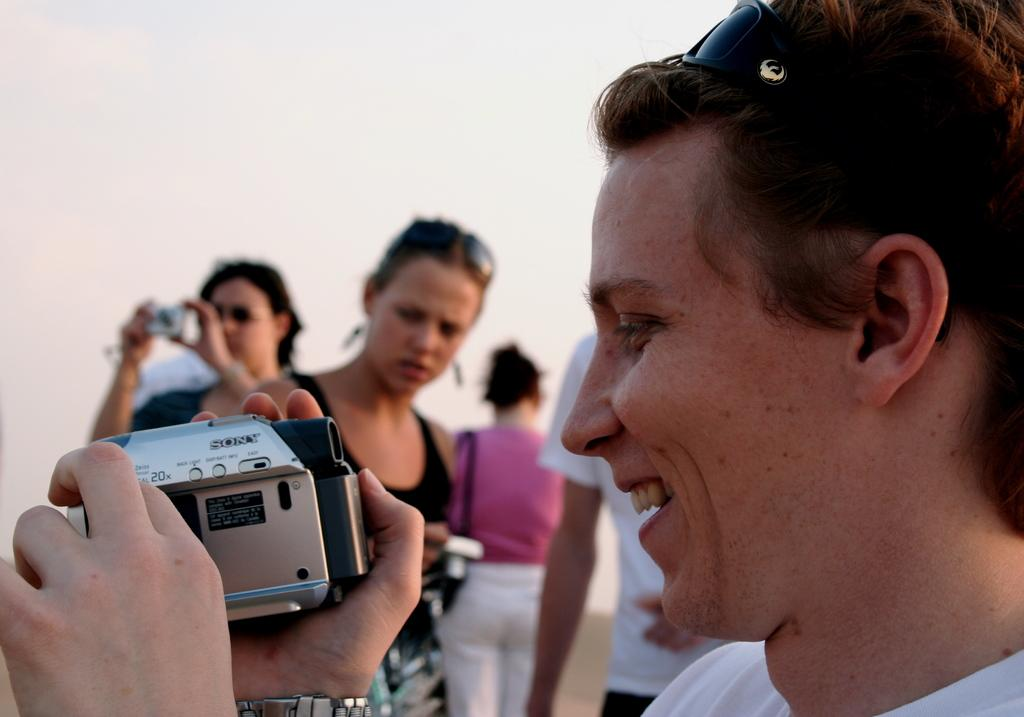Who is the main subject in the image? There is a woman in the image. What is the woman holding in her hand? The woman is holding a camera in her hand. What is the woman's facial expression in the image? The woman is smiling. Can you describe the actions of the other persons in the background of the image? There are other persons holding cameras in the background of the image. What type of brass instrument is the woman playing in the image? There is no brass instrument present in the image; the woman is holding a camera. 